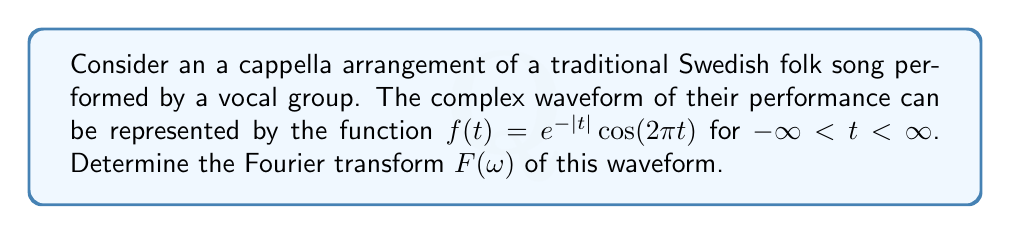What is the answer to this math problem? To find the Fourier transform of $f(t) = e^{-|t|}\cos(2\pi t)$, we'll follow these steps:

1) The Fourier transform is defined as:
   $$F(\omega) = \int_{-\infty}^{\infty} f(t) e^{-i\omega t} dt$$

2) We can rewrite $\cos(2\pi t)$ using Euler's formula:
   $$\cos(2\pi t) = \frac{1}{2}(e^{2\pi i t} + e^{-2\pi i t})$$

3) Substituting this into our function:
   $$f(t) = \frac{1}{2}e^{-|t|}(e^{2\pi i t} + e^{-2\pi i t})$$

4) Now our Fourier transform becomes:
   $$F(\omega) = \frac{1}{2}\int_{-\infty}^{\infty} e^{-|t|}(e^{2\pi i t} + e^{-2\pi i t})e^{-i\omega t} dt$$

5) This can be split into two integrals:
   $$F(\omega) = \frac{1}{2}\int_{-\infty}^{\infty} e^{-|t|}e^{(2\pi-\omega)i t} dt + \frac{1}{2}\int_{-\infty}^{\infty} e^{-|t|}e^{-(2\pi+\omega)i t} dt$$

6) Each of these integrals is of the form $\int_{-\infty}^{\infty} e^{-|t|}e^{i\alpha t} dt$, which has a known solution:
   $$\int_{-\infty}^{\infty} e^{-|t|}e^{i\alpha t} dt = \frac{2}{1+\alpha^2}$$

7) Applying this to our integrals:
   $$F(\omega) = \frac{1}{2}\cdot\frac{2}{1+(2\pi-\omega)^2} + \frac{1}{2}\cdot\frac{2}{1+(2\pi+\omega)^2}$$

8) Simplifying:
   $$F(\omega) = \frac{1}{1+(2\pi-\omega)^2} + \frac{1}{1+(2\pi+\omega)^2}$$

This is the Fourier transform of our a cappella waveform.
Answer: $$F(\omega) = \frac{1}{1+(2\pi-\omega)^2} + \frac{1}{1+(2\pi+\omega)^2}$$ 